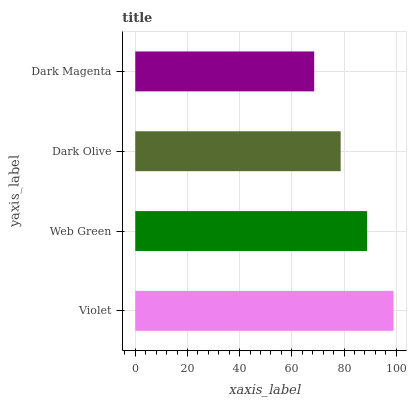Is Dark Magenta the minimum?
Answer yes or no. Yes. Is Violet the maximum?
Answer yes or no. Yes. Is Web Green the minimum?
Answer yes or no. No. Is Web Green the maximum?
Answer yes or no. No. Is Violet greater than Web Green?
Answer yes or no. Yes. Is Web Green less than Violet?
Answer yes or no. Yes. Is Web Green greater than Violet?
Answer yes or no. No. Is Violet less than Web Green?
Answer yes or no. No. Is Web Green the high median?
Answer yes or no. Yes. Is Dark Olive the low median?
Answer yes or no. Yes. Is Dark Olive the high median?
Answer yes or no. No. Is Dark Magenta the low median?
Answer yes or no. No. 